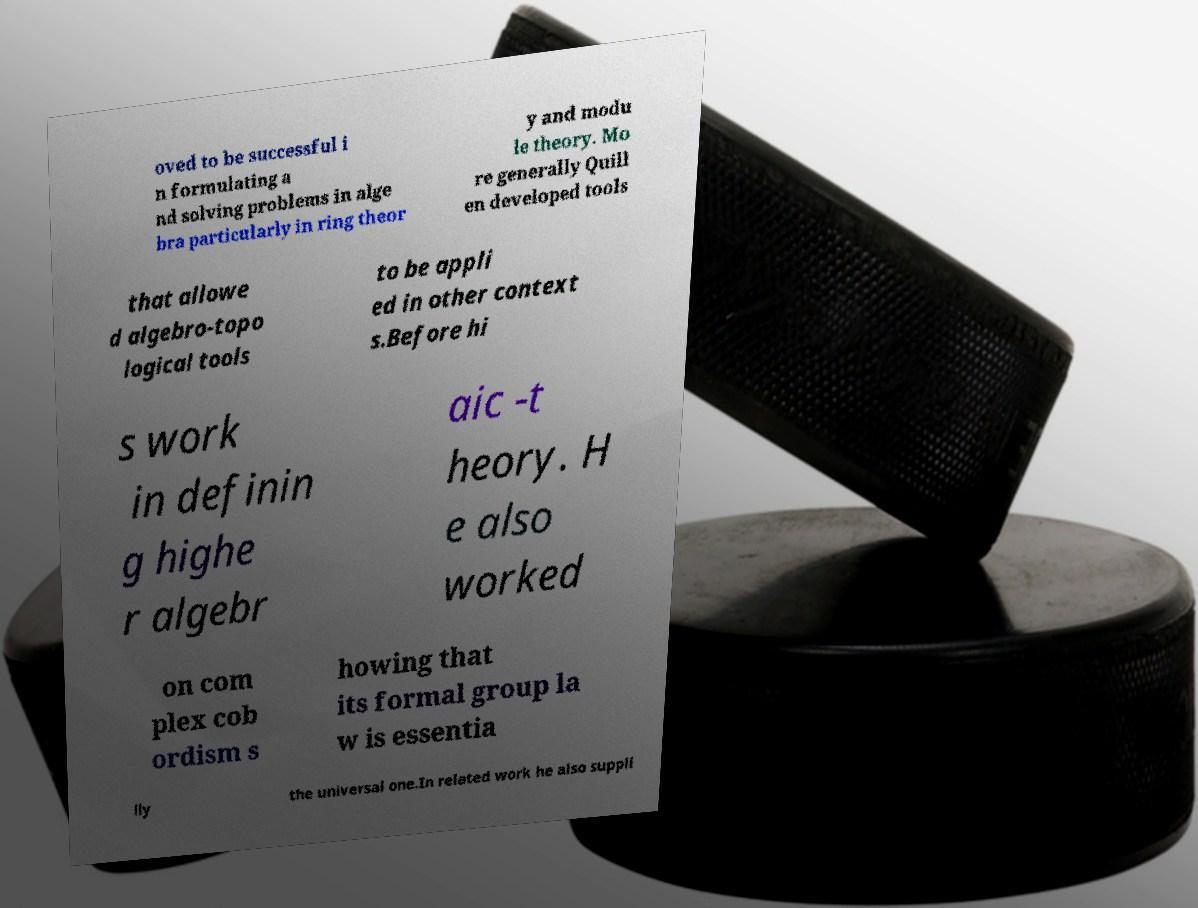I need the written content from this picture converted into text. Can you do that? oved to be successful i n formulating a nd solving problems in alge bra particularly in ring theor y and modu le theory. Mo re generally Quill en developed tools that allowe d algebro-topo logical tools to be appli ed in other context s.Before hi s work in definin g highe r algebr aic -t heory. H e also worked on com plex cob ordism s howing that its formal group la w is essentia lly the universal one.In related work he also suppli 